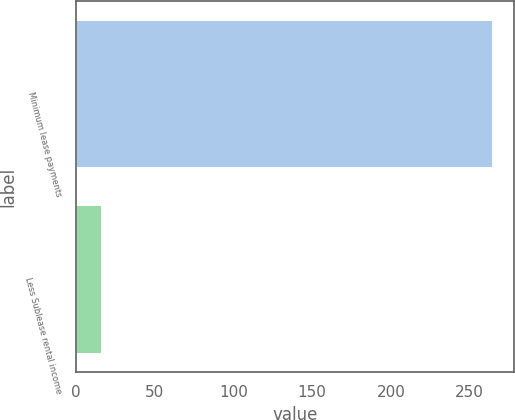Convert chart. <chart><loc_0><loc_0><loc_500><loc_500><bar_chart><fcel>Minimum lease payments<fcel>Less Sublease rental income<nl><fcel>265<fcel>17<nl></chart> 